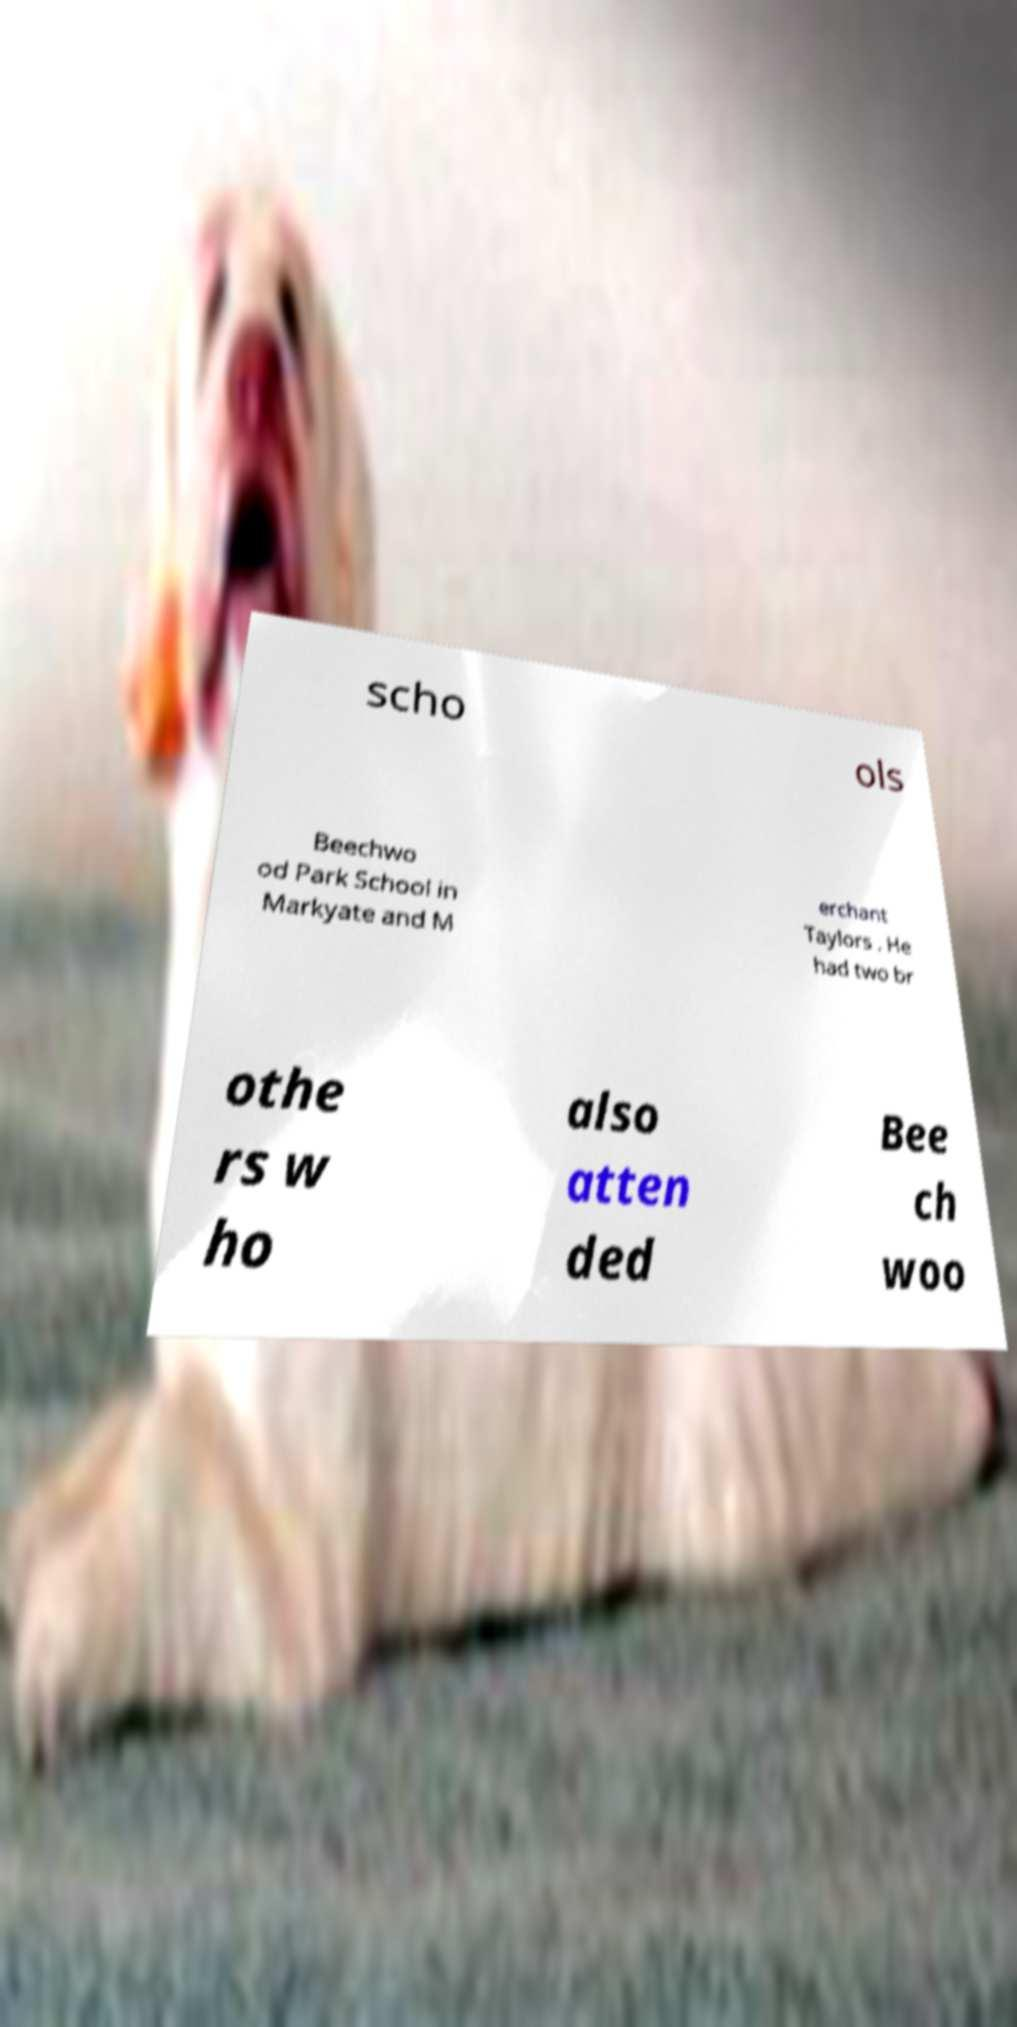What messages or text are displayed in this image? I need them in a readable, typed format. scho ols Beechwo od Park School in Markyate and M erchant Taylors . He had two br othe rs w ho also atten ded Bee ch woo 